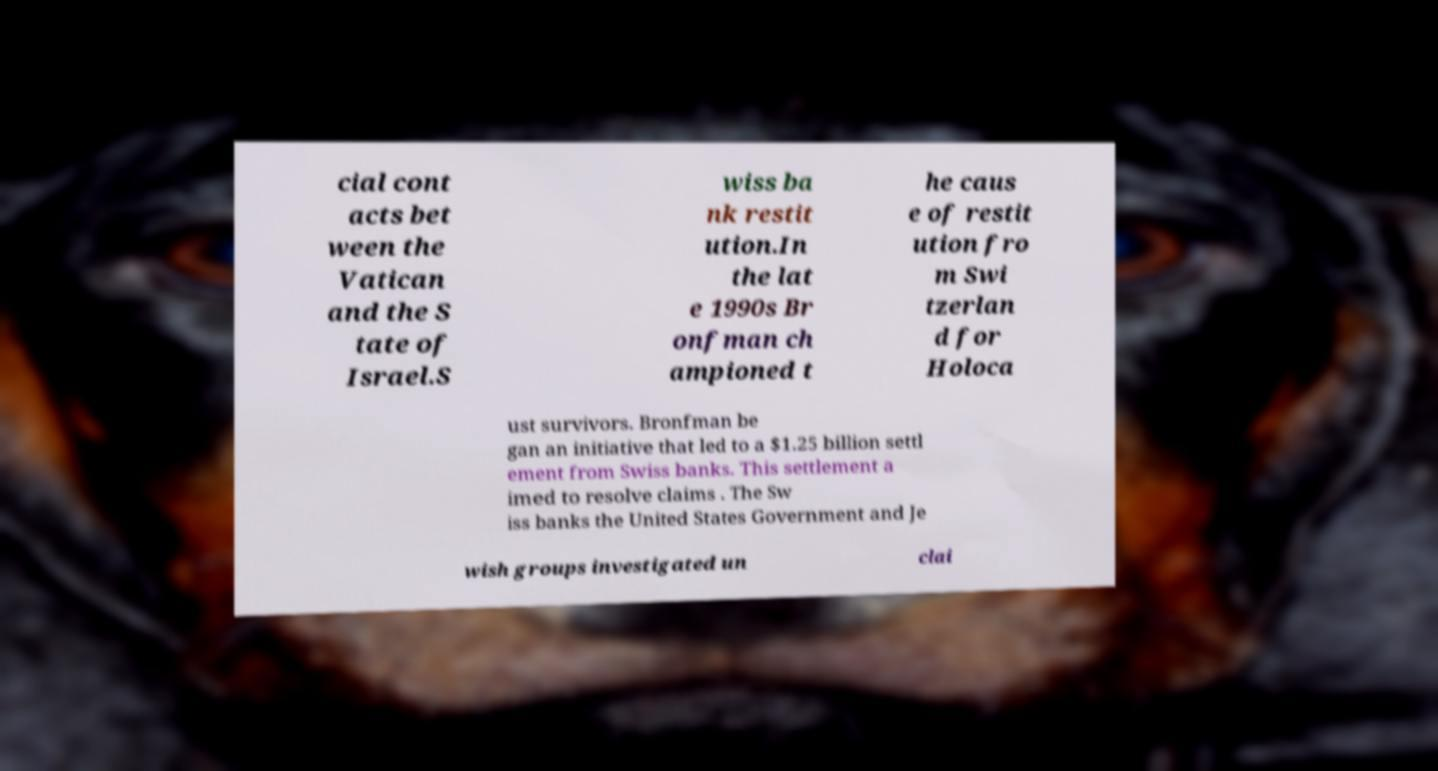Please identify and transcribe the text found in this image. cial cont acts bet ween the Vatican and the S tate of Israel.S wiss ba nk restit ution.In the lat e 1990s Br onfman ch ampioned t he caus e of restit ution fro m Swi tzerlan d for Holoca ust survivors. Bronfman be gan an initiative that led to a $1.25 billion settl ement from Swiss banks. This settlement a imed to resolve claims . The Sw iss banks the United States Government and Je wish groups investigated un clai 